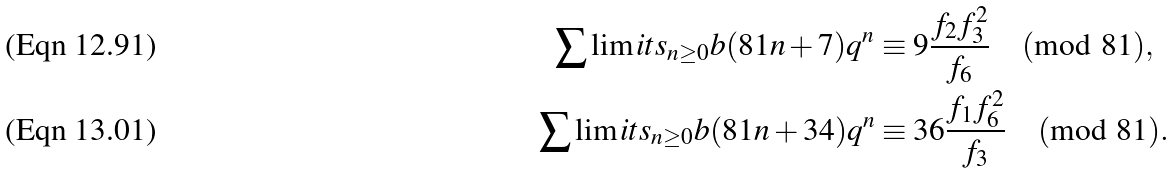Convert formula to latex. <formula><loc_0><loc_0><loc_500><loc_500>\sum \lim i t s _ { n \geq 0 } b ( 8 1 n + 7 ) q ^ { n } & \equiv 9 \frac { f _ { 2 } f _ { 3 } ^ { 2 } } { f _ { 6 } } \pmod { 8 1 } , \\ \sum \lim i t s _ { n \geq 0 } b ( 8 1 n + 3 4 ) q ^ { n } & \equiv 3 6 \frac { f _ { 1 } f _ { 6 } ^ { 2 } } { f _ { 3 } } \pmod { 8 1 } .</formula> 